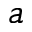Convert formula to latex. <formula><loc_0><loc_0><loc_500><loc_500>^ { \, a }</formula> 